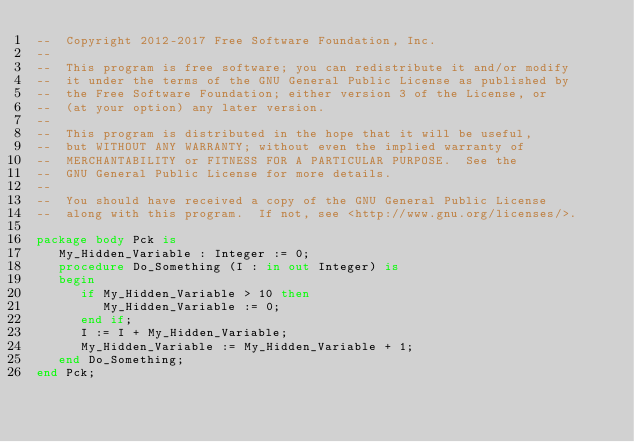Convert code to text. <code><loc_0><loc_0><loc_500><loc_500><_Ada_>--  Copyright 2012-2017 Free Software Foundation, Inc.
--
--  This program is free software; you can redistribute it and/or modify
--  it under the terms of the GNU General Public License as published by
--  the Free Software Foundation; either version 3 of the License, or
--  (at your option) any later version.
--
--  This program is distributed in the hope that it will be useful,
--  but WITHOUT ANY WARRANTY; without even the implied warranty of
--  MERCHANTABILITY or FITNESS FOR A PARTICULAR PURPOSE.  See the
--  GNU General Public License for more details.
--
--  You should have received a copy of the GNU General Public License
--  along with this program.  If not, see <http://www.gnu.org/licenses/>.

package body Pck is
   My_Hidden_Variable : Integer := 0;
   procedure Do_Something (I : in out Integer) is
   begin
      if My_Hidden_Variable > 10 then
         My_Hidden_Variable := 0;
      end if;
      I := I + My_Hidden_Variable;
      My_Hidden_Variable := My_Hidden_Variable + 1;
   end Do_Something;
end Pck;

</code> 